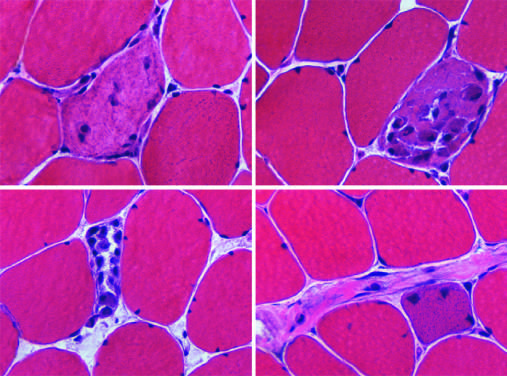re myopathic conditions associated with segmental necrosis and regeneration of individual myofibers?
Answer the question using a single word or phrase. Yes 